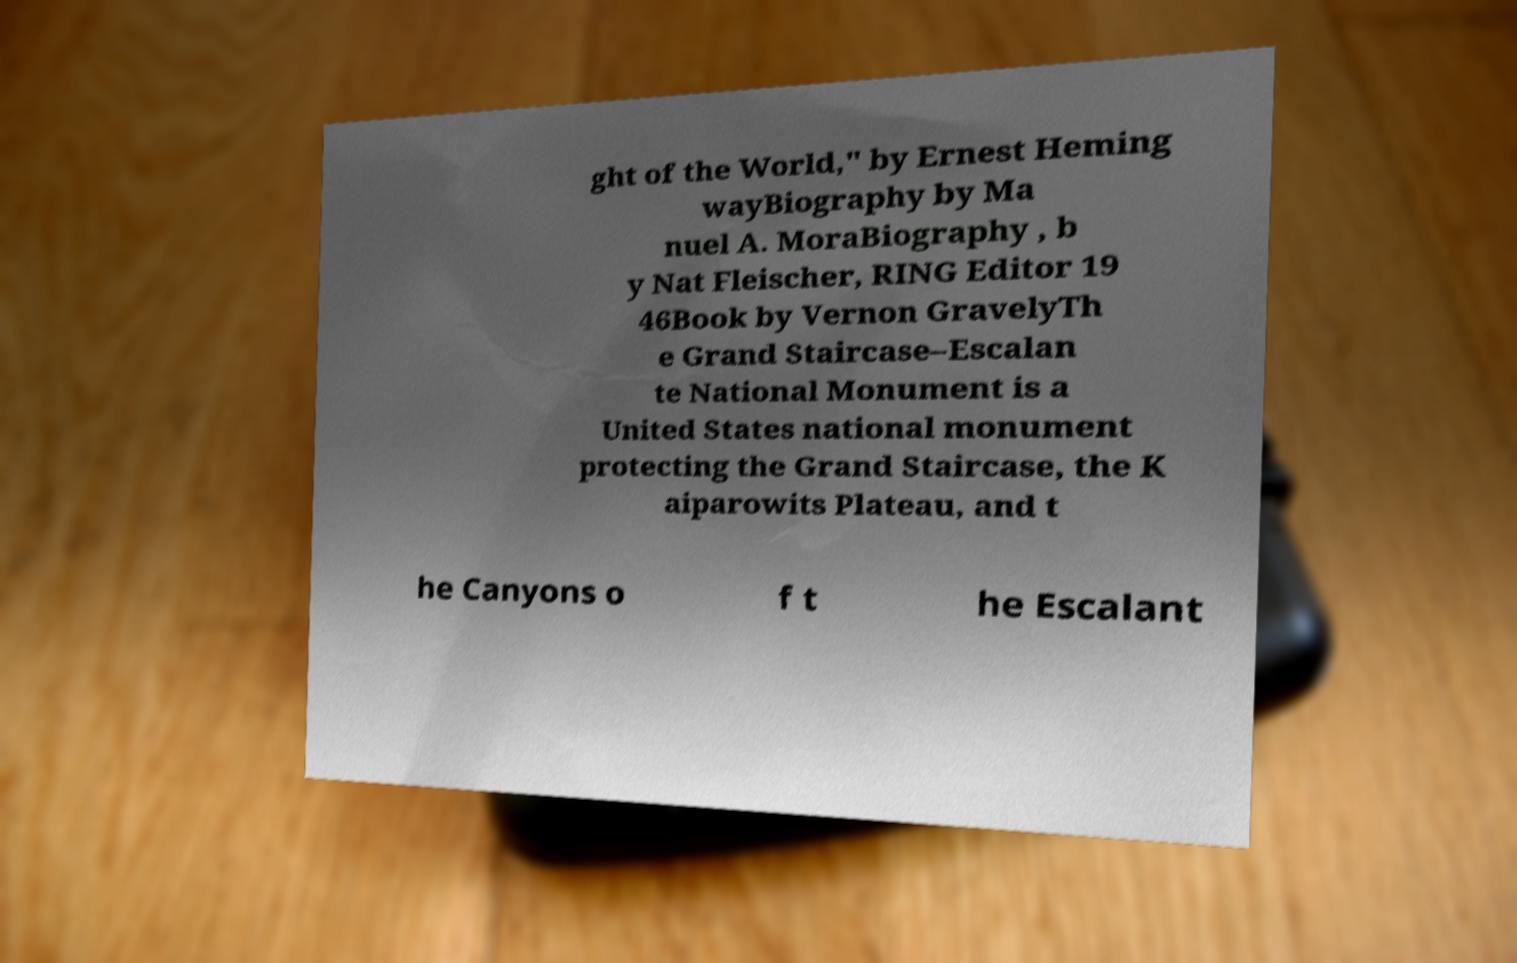Could you extract and type out the text from this image? ght of the World," by Ernest Heming wayBiography by Ma nuel A. MoraBiography , b y Nat Fleischer, RING Editor 19 46Book by Vernon GravelyTh e Grand Staircase–Escalan te National Monument is a United States national monument protecting the Grand Staircase, the K aiparowits Plateau, and t he Canyons o f t he Escalant 